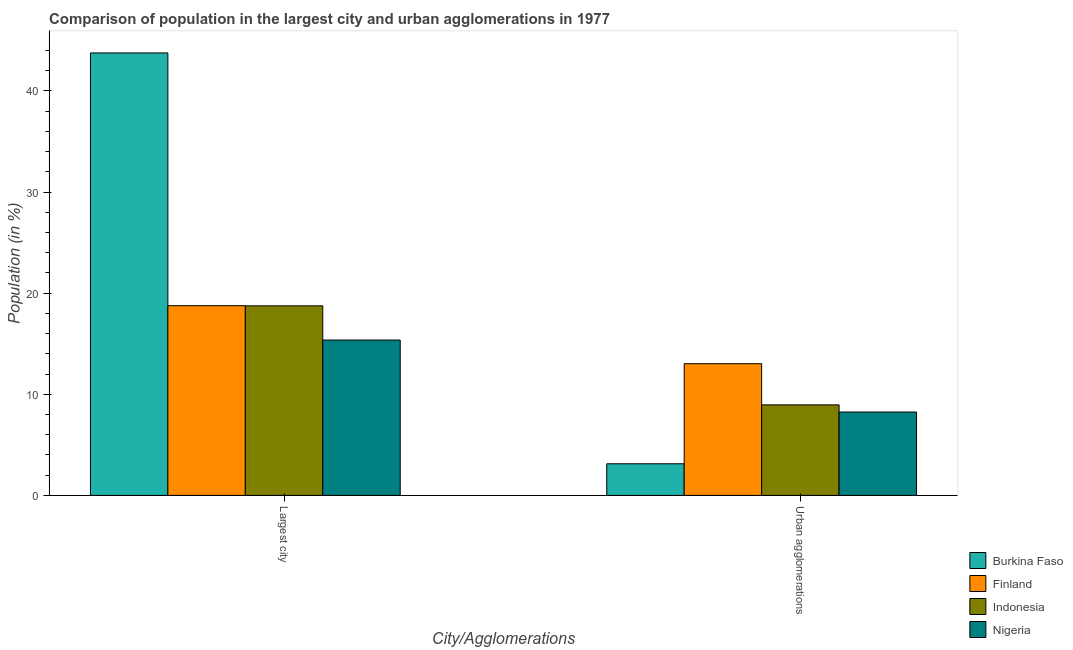How many different coloured bars are there?
Give a very brief answer. 4. How many groups of bars are there?
Provide a short and direct response. 2. Are the number of bars per tick equal to the number of legend labels?
Make the answer very short. Yes. How many bars are there on the 2nd tick from the left?
Your response must be concise. 4. How many bars are there on the 2nd tick from the right?
Offer a very short reply. 4. What is the label of the 1st group of bars from the left?
Provide a succinct answer. Largest city. What is the population in the largest city in Indonesia?
Give a very brief answer. 18.75. Across all countries, what is the maximum population in the largest city?
Your answer should be compact. 43.75. Across all countries, what is the minimum population in the largest city?
Provide a succinct answer. 15.36. In which country was the population in the largest city maximum?
Offer a very short reply. Burkina Faso. In which country was the population in urban agglomerations minimum?
Make the answer very short. Burkina Faso. What is the total population in the largest city in the graph?
Give a very brief answer. 96.63. What is the difference between the population in the largest city in Burkina Faso and that in Nigeria?
Give a very brief answer. 28.39. What is the difference between the population in urban agglomerations in Nigeria and the population in the largest city in Burkina Faso?
Give a very brief answer. -35.51. What is the average population in the largest city per country?
Your answer should be very brief. 24.16. What is the difference between the population in the largest city and population in urban agglomerations in Indonesia?
Your response must be concise. 9.79. What is the ratio of the population in the largest city in Finland to that in Indonesia?
Offer a terse response. 1. What does the 2nd bar from the right in Largest city represents?
Your answer should be compact. Indonesia. How many bars are there?
Your response must be concise. 8. How many countries are there in the graph?
Your answer should be compact. 4. What is the difference between two consecutive major ticks on the Y-axis?
Provide a short and direct response. 10. Are the values on the major ticks of Y-axis written in scientific E-notation?
Your answer should be very brief. No. Does the graph contain any zero values?
Ensure brevity in your answer.  No. Does the graph contain grids?
Provide a short and direct response. No. How many legend labels are there?
Keep it short and to the point. 4. How are the legend labels stacked?
Your answer should be compact. Vertical. What is the title of the graph?
Your response must be concise. Comparison of population in the largest city and urban agglomerations in 1977. What is the label or title of the X-axis?
Provide a short and direct response. City/Agglomerations. What is the Population (in %) in Burkina Faso in Largest city?
Keep it short and to the point. 43.75. What is the Population (in %) in Finland in Largest city?
Offer a very short reply. 18.76. What is the Population (in %) of Indonesia in Largest city?
Keep it short and to the point. 18.75. What is the Population (in %) of Nigeria in Largest city?
Keep it short and to the point. 15.36. What is the Population (in %) in Burkina Faso in Urban agglomerations?
Provide a succinct answer. 3.13. What is the Population (in %) in Finland in Urban agglomerations?
Provide a succinct answer. 13.02. What is the Population (in %) of Indonesia in Urban agglomerations?
Offer a very short reply. 8.95. What is the Population (in %) in Nigeria in Urban agglomerations?
Ensure brevity in your answer.  8.25. Across all City/Agglomerations, what is the maximum Population (in %) of Burkina Faso?
Your response must be concise. 43.75. Across all City/Agglomerations, what is the maximum Population (in %) of Finland?
Provide a short and direct response. 18.76. Across all City/Agglomerations, what is the maximum Population (in %) in Indonesia?
Your response must be concise. 18.75. Across all City/Agglomerations, what is the maximum Population (in %) of Nigeria?
Make the answer very short. 15.36. Across all City/Agglomerations, what is the minimum Population (in %) in Burkina Faso?
Offer a very short reply. 3.13. Across all City/Agglomerations, what is the minimum Population (in %) of Finland?
Provide a succinct answer. 13.02. Across all City/Agglomerations, what is the minimum Population (in %) of Indonesia?
Keep it short and to the point. 8.95. Across all City/Agglomerations, what is the minimum Population (in %) of Nigeria?
Offer a very short reply. 8.25. What is the total Population (in %) of Burkina Faso in the graph?
Offer a terse response. 46.88. What is the total Population (in %) of Finland in the graph?
Your answer should be compact. 31.79. What is the total Population (in %) in Indonesia in the graph?
Keep it short and to the point. 27.7. What is the total Population (in %) of Nigeria in the graph?
Give a very brief answer. 23.61. What is the difference between the Population (in %) of Burkina Faso in Largest city and that in Urban agglomerations?
Your response must be concise. 40.63. What is the difference between the Population (in %) in Finland in Largest city and that in Urban agglomerations?
Your answer should be very brief. 5.74. What is the difference between the Population (in %) of Indonesia in Largest city and that in Urban agglomerations?
Make the answer very short. 9.79. What is the difference between the Population (in %) in Nigeria in Largest city and that in Urban agglomerations?
Make the answer very short. 7.12. What is the difference between the Population (in %) in Burkina Faso in Largest city and the Population (in %) in Finland in Urban agglomerations?
Make the answer very short. 30.73. What is the difference between the Population (in %) of Burkina Faso in Largest city and the Population (in %) of Indonesia in Urban agglomerations?
Ensure brevity in your answer.  34.8. What is the difference between the Population (in %) in Burkina Faso in Largest city and the Population (in %) in Nigeria in Urban agglomerations?
Provide a short and direct response. 35.51. What is the difference between the Population (in %) of Finland in Largest city and the Population (in %) of Indonesia in Urban agglomerations?
Your answer should be compact. 9.81. What is the difference between the Population (in %) of Finland in Largest city and the Population (in %) of Nigeria in Urban agglomerations?
Provide a short and direct response. 10.52. What is the difference between the Population (in %) in Indonesia in Largest city and the Population (in %) in Nigeria in Urban agglomerations?
Keep it short and to the point. 10.5. What is the average Population (in %) of Burkina Faso per City/Agglomerations?
Offer a very short reply. 23.44. What is the average Population (in %) in Finland per City/Agglomerations?
Ensure brevity in your answer.  15.89. What is the average Population (in %) of Indonesia per City/Agglomerations?
Provide a succinct answer. 13.85. What is the average Population (in %) in Nigeria per City/Agglomerations?
Ensure brevity in your answer.  11.8. What is the difference between the Population (in %) in Burkina Faso and Population (in %) in Finland in Largest city?
Your answer should be compact. 24.99. What is the difference between the Population (in %) in Burkina Faso and Population (in %) in Indonesia in Largest city?
Your answer should be compact. 25.01. What is the difference between the Population (in %) in Burkina Faso and Population (in %) in Nigeria in Largest city?
Offer a very short reply. 28.39. What is the difference between the Population (in %) in Finland and Population (in %) in Indonesia in Largest city?
Keep it short and to the point. 0.01. What is the difference between the Population (in %) in Finland and Population (in %) in Nigeria in Largest city?
Make the answer very short. 3.4. What is the difference between the Population (in %) of Indonesia and Population (in %) of Nigeria in Largest city?
Provide a succinct answer. 3.38. What is the difference between the Population (in %) of Burkina Faso and Population (in %) of Finland in Urban agglomerations?
Make the answer very short. -9.9. What is the difference between the Population (in %) in Burkina Faso and Population (in %) in Indonesia in Urban agglomerations?
Your answer should be very brief. -5.82. What is the difference between the Population (in %) in Burkina Faso and Population (in %) in Nigeria in Urban agglomerations?
Provide a succinct answer. -5.12. What is the difference between the Population (in %) of Finland and Population (in %) of Indonesia in Urban agglomerations?
Provide a short and direct response. 4.07. What is the difference between the Population (in %) in Finland and Population (in %) in Nigeria in Urban agglomerations?
Make the answer very short. 4.78. What is the difference between the Population (in %) in Indonesia and Population (in %) in Nigeria in Urban agglomerations?
Your answer should be compact. 0.71. What is the ratio of the Population (in %) of Burkina Faso in Largest city to that in Urban agglomerations?
Offer a very short reply. 13.98. What is the ratio of the Population (in %) of Finland in Largest city to that in Urban agglomerations?
Provide a short and direct response. 1.44. What is the ratio of the Population (in %) in Indonesia in Largest city to that in Urban agglomerations?
Your response must be concise. 2.09. What is the ratio of the Population (in %) of Nigeria in Largest city to that in Urban agglomerations?
Provide a short and direct response. 1.86. What is the difference between the highest and the second highest Population (in %) in Burkina Faso?
Your answer should be compact. 40.63. What is the difference between the highest and the second highest Population (in %) in Finland?
Make the answer very short. 5.74. What is the difference between the highest and the second highest Population (in %) in Indonesia?
Give a very brief answer. 9.79. What is the difference between the highest and the second highest Population (in %) in Nigeria?
Give a very brief answer. 7.12. What is the difference between the highest and the lowest Population (in %) in Burkina Faso?
Your answer should be very brief. 40.63. What is the difference between the highest and the lowest Population (in %) of Finland?
Ensure brevity in your answer.  5.74. What is the difference between the highest and the lowest Population (in %) of Indonesia?
Keep it short and to the point. 9.79. What is the difference between the highest and the lowest Population (in %) in Nigeria?
Give a very brief answer. 7.12. 